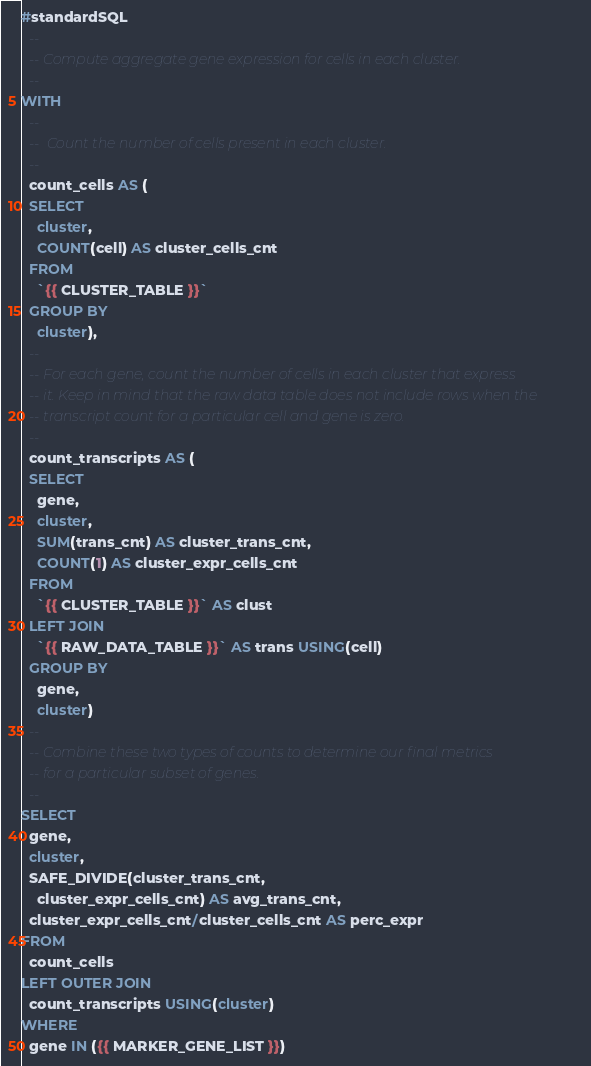Convert code to text. <code><loc_0><loc_0><loc_500><loc_500><_SQL_>#standardSQL
  --
  -- Compute aggregate gene expression for cells in each cluster.
  --
WITH
  --
  --  Count the number of cells present in each cluster.
  --
  count_cells AS (
  SELECT
    cluster,
    COUNT(cell) AS cluster_cells_cnt
  FROM
    `{{ CLUSTER_TABLE }}`
  GROUP BY
    cluster),
  --
  -- For each gene, count the number of cells in each cluster that express
  -- it. Keep in mind that the raw data table does not include rows when the
  -- transcript count for a particular cell and gene is zero.
  --
  count_transcripts AS (
  SELECT
    gene,
    cluster,
    SUM(trans_cnt) AS cluster_trans_cnt,
    COUNT(1) AS cluster_expr_cells_cnt
  FROM
    `{{ CLUSTER_TABLE }}` AS clust
  LEFT JOIN
    `{{ RAW_DATA_TABLE }}` AS trans USING(cell)
  GROUP BY
    gene,
    cluster)
  --
  -- Combine these two types of counts to determine our final metrics
  -- for a particular subset of genes.
  --
SELECT
  gene,
  cluster,
  SAFE_DIVIDE(cluster_trans_cnt,
    cluster_expr_cells_cnt) AS avg_trans_cnt,
  cluster_expr_cells_cnt/cluster_cells_cnt AS perc_expr
FROM
  count_cells
LEFT OUTER JOIN
  count_transcripts USING(cluster)
WHERE
  gene IN ({{ MARKER_GENE_LIST }})
</code> 